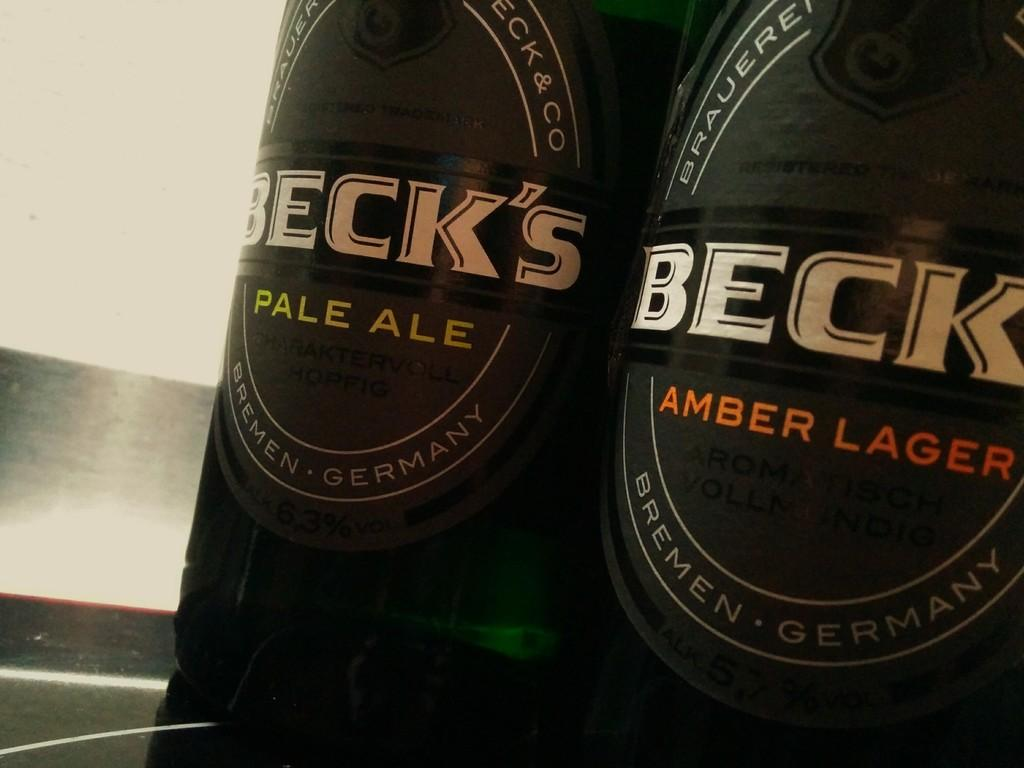<image>
Provide a brief description of the given image. Two bottles of Becks amber lager sit on a counter 